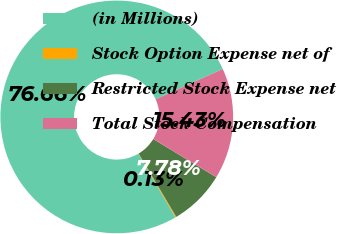Convert chart to OTSL. <chart><loc_0><loc_0><loc_500><loc_500><pie_chart><fcel>(in Millions)<fcel>Stock Option Expense net of<fcel>Restricted Stock Expense net<fcel>Total Stock Compensation<nl><fcel>76.66%<fcel>0.13%<fcel>7.78%<fcel>15.43%<nl></chart> 